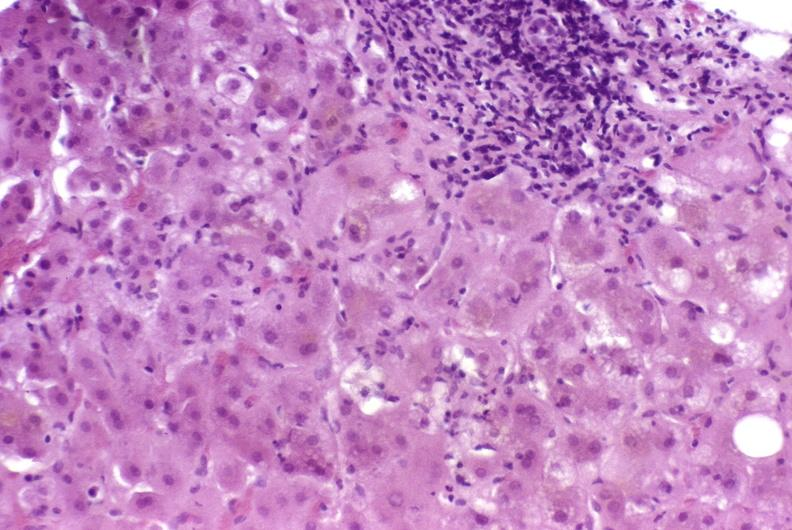s liver present?
Answer the question using a single word or phrase. Yes 